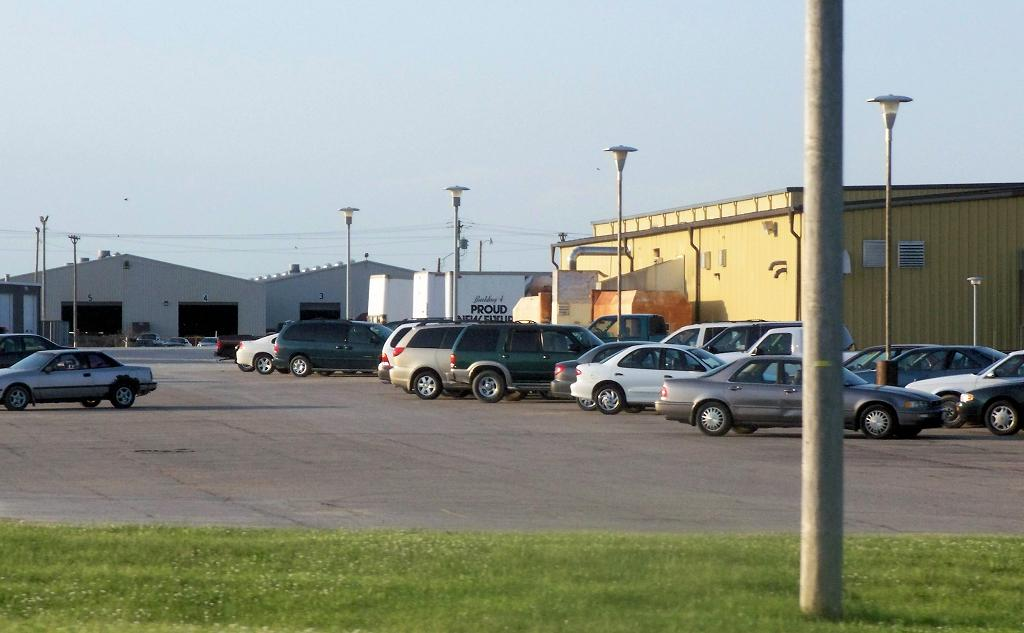What types of objects are present in the image? There are vehicles and light poles in the image. What can be seen in the background of the image? There are sheds in the background of the image. What is the color of the sky in the image? The sky is white in color. How many curtains are hanging from the vehicles in the image? There are no curtains present in the image; it features vehicles, light poles, sheds, and a white sky. 